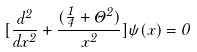Convert formula to latex. <formula><loc_0><loc_0><loc_500><loc_500>[ \frac { d ^ { 2 } } { d x ^ { 2 } } + \frac { ( \frac { 1 } { 4 } + \Theta ^ { 2 } ) } { x ^ { 2 } } ] \psi ( x ) = 0</formula> 